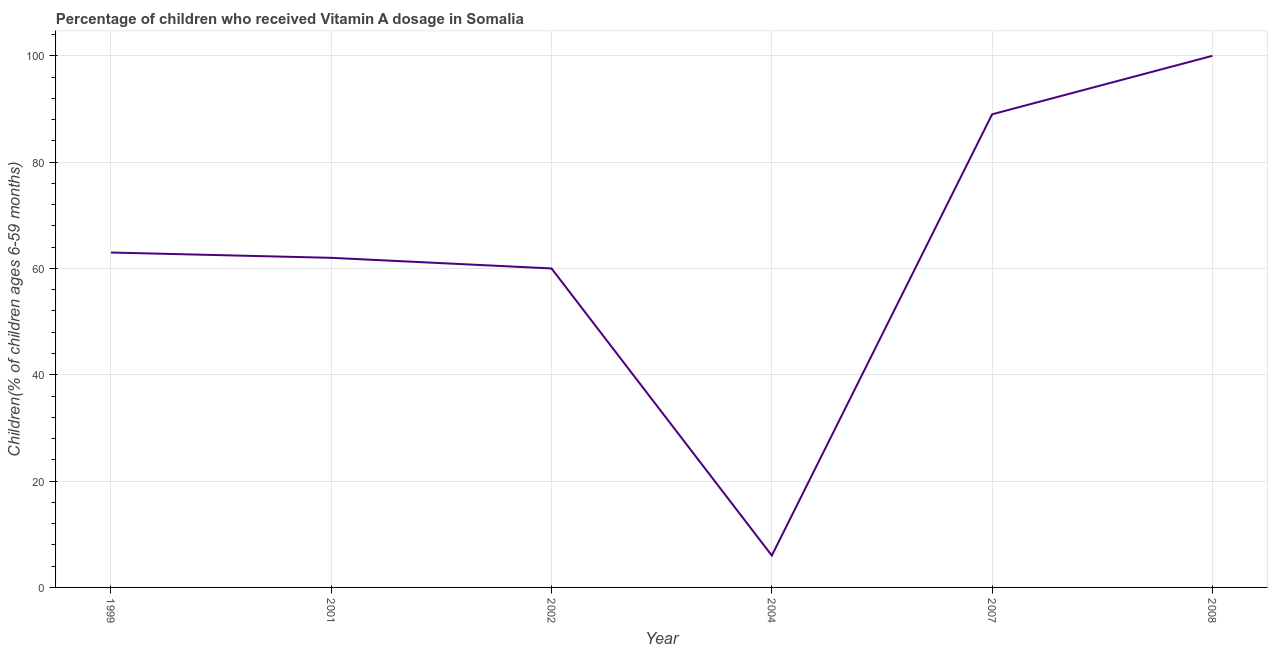What is the vitamin a supplementation coverage rate in 2004?
Your response must be concise. 6. Across all years, what is the maximum vitamin a supplementation coverage rate?
Ensure brevity in your answer.  100. Across all years, what is the minimum vitamin a supplementation coverage rate?
Your response must be concise. 6. In which year was the vitamin a supplementation coverage rate maximum?
Ensure brevity in your answer.  2008. In which year was the vitamin a supplementation coverage rate minimum?
Your answer should be very brief. 2004. What is the sum of the vitamin a supplementation coverage rate?
Ensure brevity in your answer.  380. What is the difference between the vitamin a supplementation coverage rate in 2002 and 2008?
Ensure brevity in your answer.  -40. What is the average vitamin a supplementation coverage rate per year?
Provide a short and direct response. 63.33. What is the median vitamin a supplementation coverage rate?
Keep it short and to the point. 62.5. In how many years, is the vitamin a supplementation coverage rate greater than 28 %?
Make the answer very short. 5. Is the vitamin a supplementation coverage rate in 1999 less than that in 2001?
Offer a very short reply. No. What is the difference between the highest and the second highest vitamin a supplementation coverage rate?
Give a very brief answer. 11. What is the difference between the highest and the lowest vitamin a supplementation coverage rate?
Your answer should be very brief. 94. In how many years, is the vitamin a supplementation coverage rate greater than the average vitamin a supplementation coverage rate taken over all years?
Offer a very short reply. 2. How many years are there in the graph?
Your answer should be compact. 6. What is the title of the graph?
Give a very brief answer. Percentage of children who received Vitamin A dosage in Somalia. What is the label or title of the X-axis?
Provide a short and direct response. Year. What is the label or title of the Y-axis?
Make the answer very short. Children(% of children ages 6-59 months). What is the Children(% of children ages 6-59 months) of 2004?
Provide a short and direct response. 6. What is the Children(% of children ages 6-59 months) of 2007?
Your answer should be very brief. 89. What is the difference between the Children(% of children ages 6-59 months) in 1999 and 2002?
Your answer should be compact. 3. What is the difference between the Children(% of children ages 6-59 months) in 1999 and 2007?
Provide a succinct answer. -26. What is the difference between the Children(% of children ages 6-59 months) in 1999 and 2008?
Your answer should be very brief. -37. What is the difference between the Children(% of children ages 6-59 months) in 2001 and 2002?
Provide a short and direct response. 2. What is the difference between the Children(% of children ages 6-59 months) in 2001 and 2004?
Offer a terse response. 56. What is the difference between the Children(% of children ages 6-59 months) in 2001 and 2008?
Your answer should be very brief. -38. What is the difference between the Children(% of children ages 6-59 months) in 2002 and 2004?
Your response must be concise. 54. What is the difference between the Children(% of children ages 6-59 months) in 2002 and 2007?
Your answer should be very brief. -29. What is the difference between the Children(% of children ages 6-59 months) in 2004 and 2007?
Offer a very short reply. -83. What is the difference between the Children(% of children ages 6-59 months) in 2004 and 2008?
Ensure brevity in your answer.  -94. What is the difference between the Children(% of children ages 6-59 months) in 2007 and 2008?
Your response must be concise. -11. What is the ratio of the Children(% of children ages 6-59 months) in 1999 to that in 2001?
Keep it short and to the point. 1.02. What is the ratio of the Children(% of children ages 6-59 months) in 1999 to that in 2002?
Offer a terse response. 1.05. What is the ratio of the Children(% of children ages 6-59 months) in 1999 to that in 2004?
Provide a short and direct response. 10.5. What is the ratio of the Children(% of children ages 6-59 months) in 1999 to that in 2007?
Make the answer very short. 0.71. What is the ratio of the Children(% of children ages 6-59 months) in 1999 to that in 2008?
Make the answer very short. 0.63. What is the ratio of the Children(% of children ages 6-59 months) in 2001 to that in 2002?
Offer a terse response. 1.03. What is the ratio of the Children(% of children ages 6-59 months) in 2001 to that in 2004?
Keep it short and to the point. 10.33. What is the ratio of the Children(% of children ages 6-59 months) in 2001 to that in 2007?
Your answer should be compact. 0.7. What is the ratio of the Children(% of children ages 6-59 months) in 2001 to that in 2008?
Your response must be concise. 0.62. What is the ratio of the Children(% of children ages 6-59 months) in 2002 to that in 2004?
Provide a short and direct response. 10. What is the ratio of the Children(% of children ages 6-59 months) in 2002 to that in 2007?
Offer a very short reply. 0.67. What is the ratio of the Children(% of children ages 6-59 months) in 2002 to that in 2008?
Ensure brevity in your answer.  0.6. What is the ratio of the Children(% of children ages 6-59 months) in 2004 to that in 2007?
Give a very brief answer. 0.07. What is the ratio of the Children(% of children ages 6-59 months) in 2004 to that in 2008?
Your answer should be compact. 0.06. What is the ratio of the Children(% of children ages 6-59 months) in 2007 to that in 2008?
Make the answer very short. 0.89. 